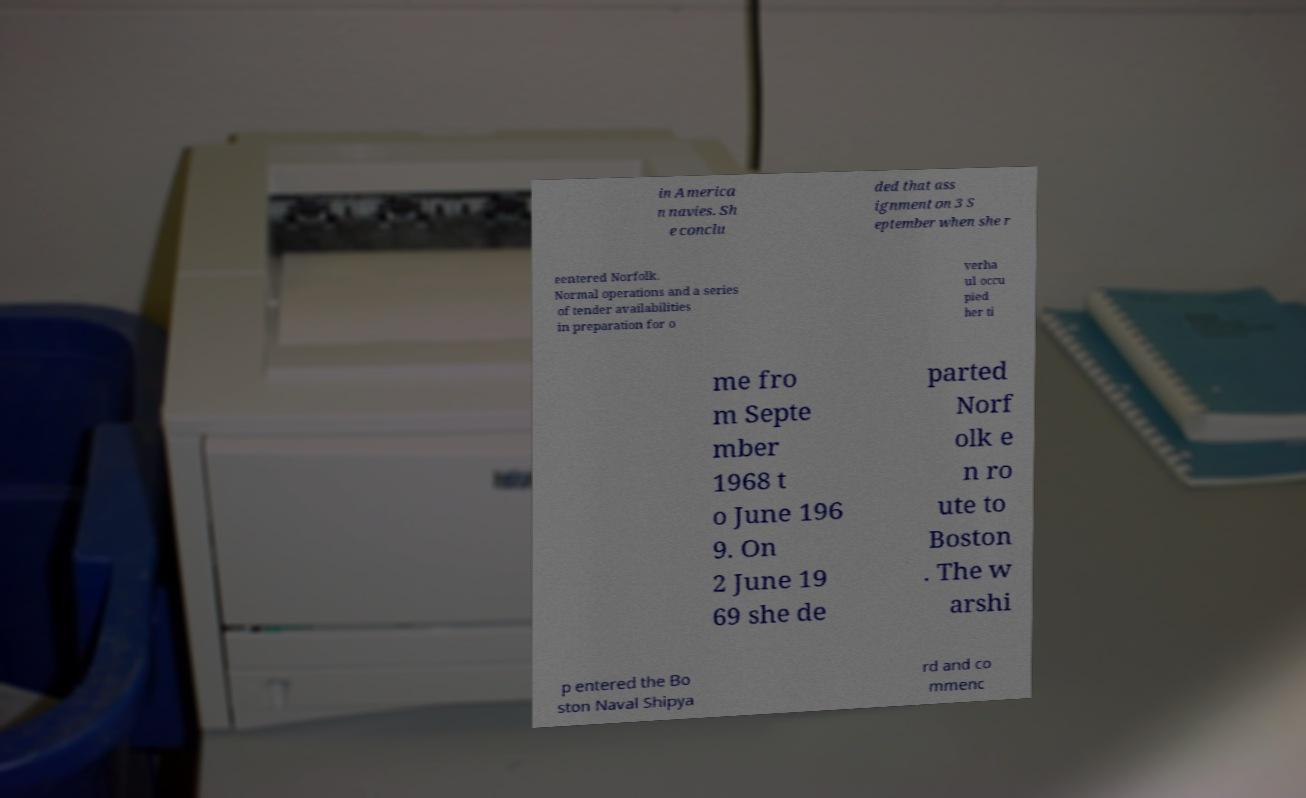For documentation purposes, I need the text within this image transcribed. Could you provide that? in America n navies. Sh e conclu ded that ass ignment on 3 S eptember when she r eentered Norfolk. Normal operations and a series of tender availabilities in preparation for o verha ul occu pied her ti me fro m Septe mber 1968 t o June 196 9. On 2 June 19 69 she de parted Norf olk e n ro ute to Boston . The w arshi p entered the Bo ston Naval Shipya rd and co mmenc 